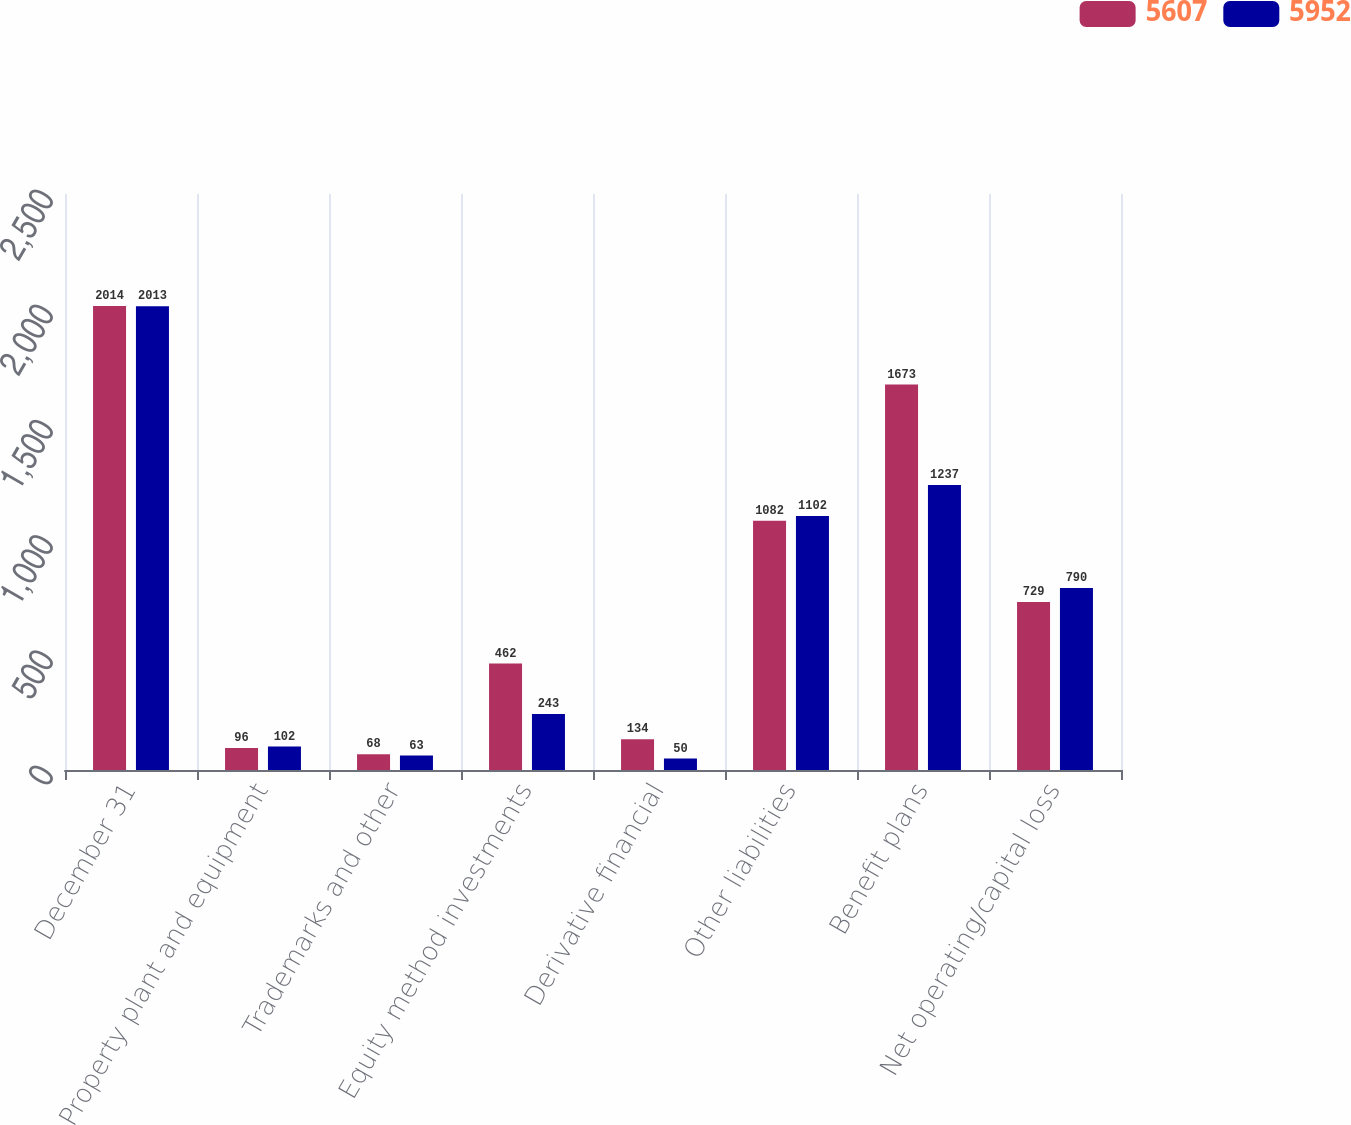Convert chart. <chart><loc_0><loc_0><loc_500><loc_500><stacked_bar_chart><ecel><fcel>December 31<fcel>Property plant and equipment<fcel>Trademarks and other<fcel>Equity method investments<fcel>Derivative financial<fcel>Other liabilities<fcel>Benefit plans<fcel>Net operating/capital loss<nl><fcel>5607<fcel>2014<fcel>96<fcel>68<fcel>462<fcel>134<fcel>1082<fcel>1673<fcel>729<nl><fcel>5952<fcel>2013<fcel>102<fcel>63<fcel>243<fcel>50<fcel>1102<fcel>1237<fcel>790<nl></chart> 